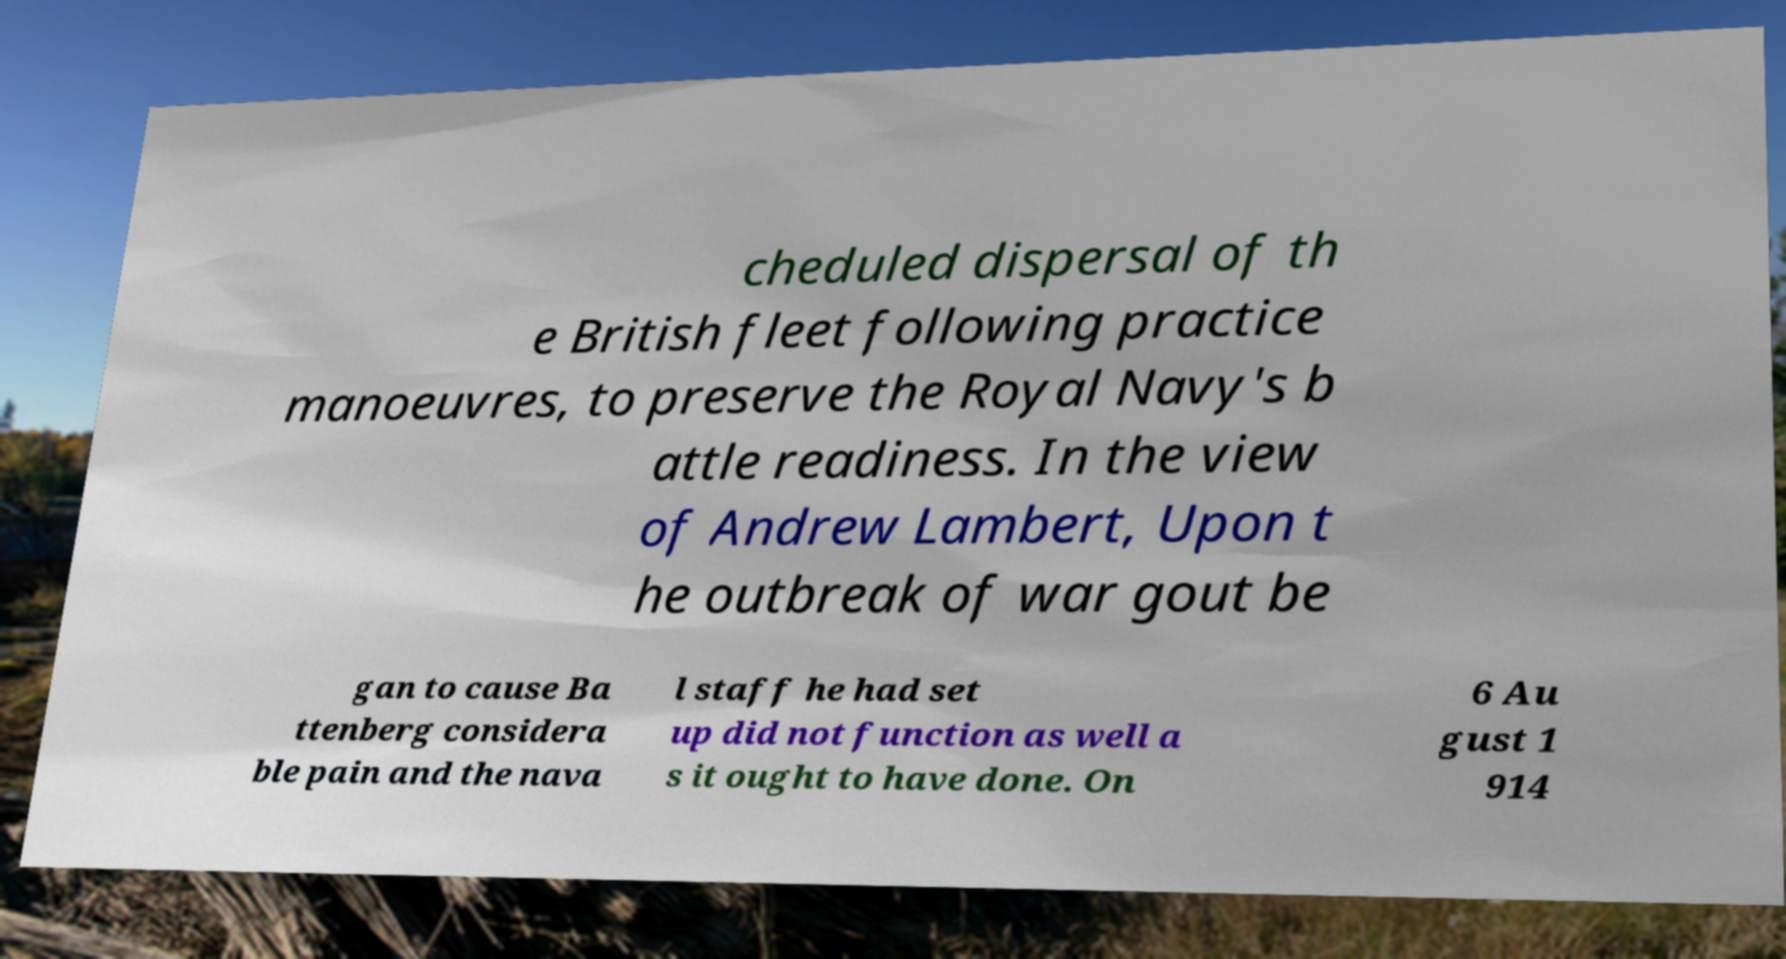Please identify and transcribe the text found in this image. cheduled dispersal of th e British fleet following practice manoeuvres, to preserve the Royal Navy's b attle readiness. In the view of Andrew Lambert, Upon t he outbreak of war gout be gan to cause Ba ttenberg considera ble pain and the nava l staff he had set up did not function as well a s it ought to have done. On 6 Au gust 1 914 